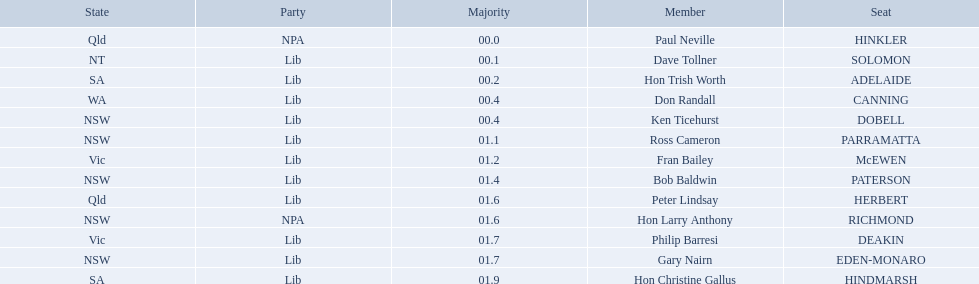Which seats are represented in the electoral system of australia? HINKLER, SOLOMON, ADELAIDE, CANNING, DOBELL, PARRAMATTA, McEWEN, PATERSON, HERBERT, RICHMOND, DEAKIN, EDEN-MONARO, HINDMARSH. What were their majority numbers of both hindmarsh and hinkler? HINKLER, HINDMARSH. Of those two seats, what is the difference in voting majority? 01.9. 